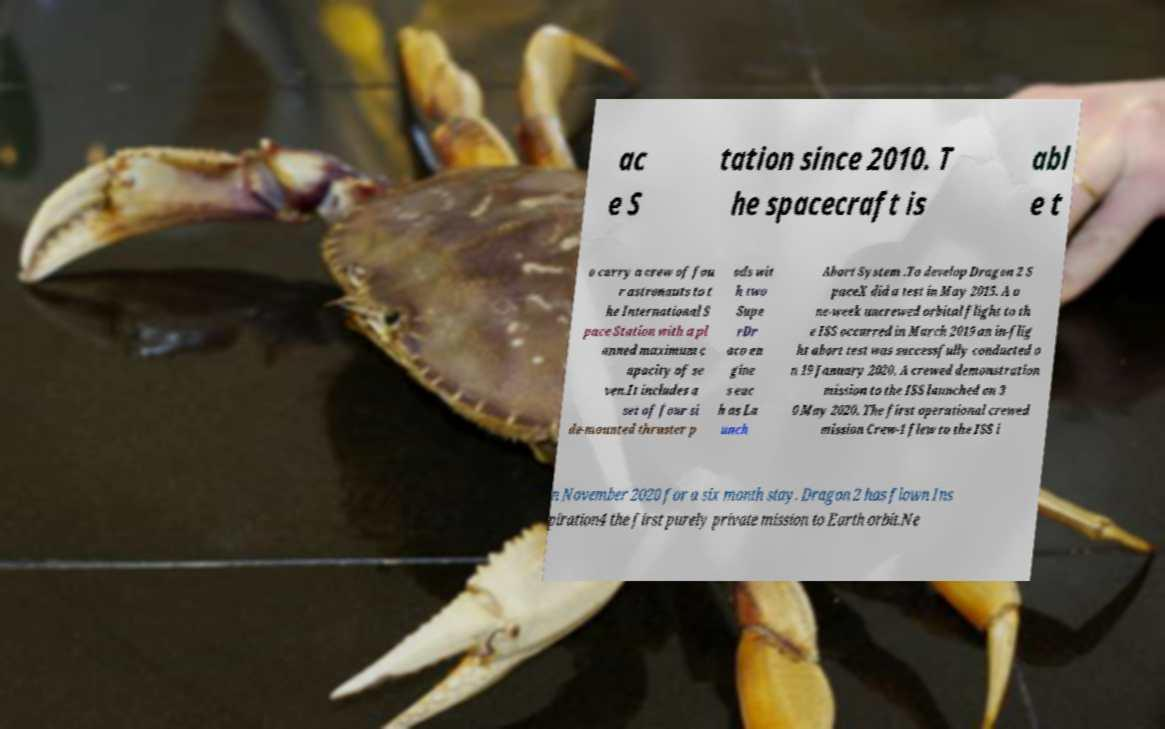Please read and relay the text visible in this image. What does it say? ac e S tation since 2010. T he spacecraft is abl e t o carry a crew of fou r astronauts to t he International S pace Station with a pl anned maximum c apacity of se ven.It includes a set of four si de-mounted thruster p ods wit h two Supe rDr aco en gine s eac h as La unch Abort System .To develop Dragon 2 S paceX did a test in May 2015. A o ne-week uncrewed orbital flight to th e ISS occurred in March 2019 an in-flig ht abort test was successfully conducted o n 19 January 2020. A crewed demonstration mission to the ISS launched on 3 0 May 2020. The first operational crewed mission Crew-1 flew to the ISS i n November 2020 for a six month stay. Dragon 2 has flown Ins piration4 the first purely private mission to Earth orbit.Ne 